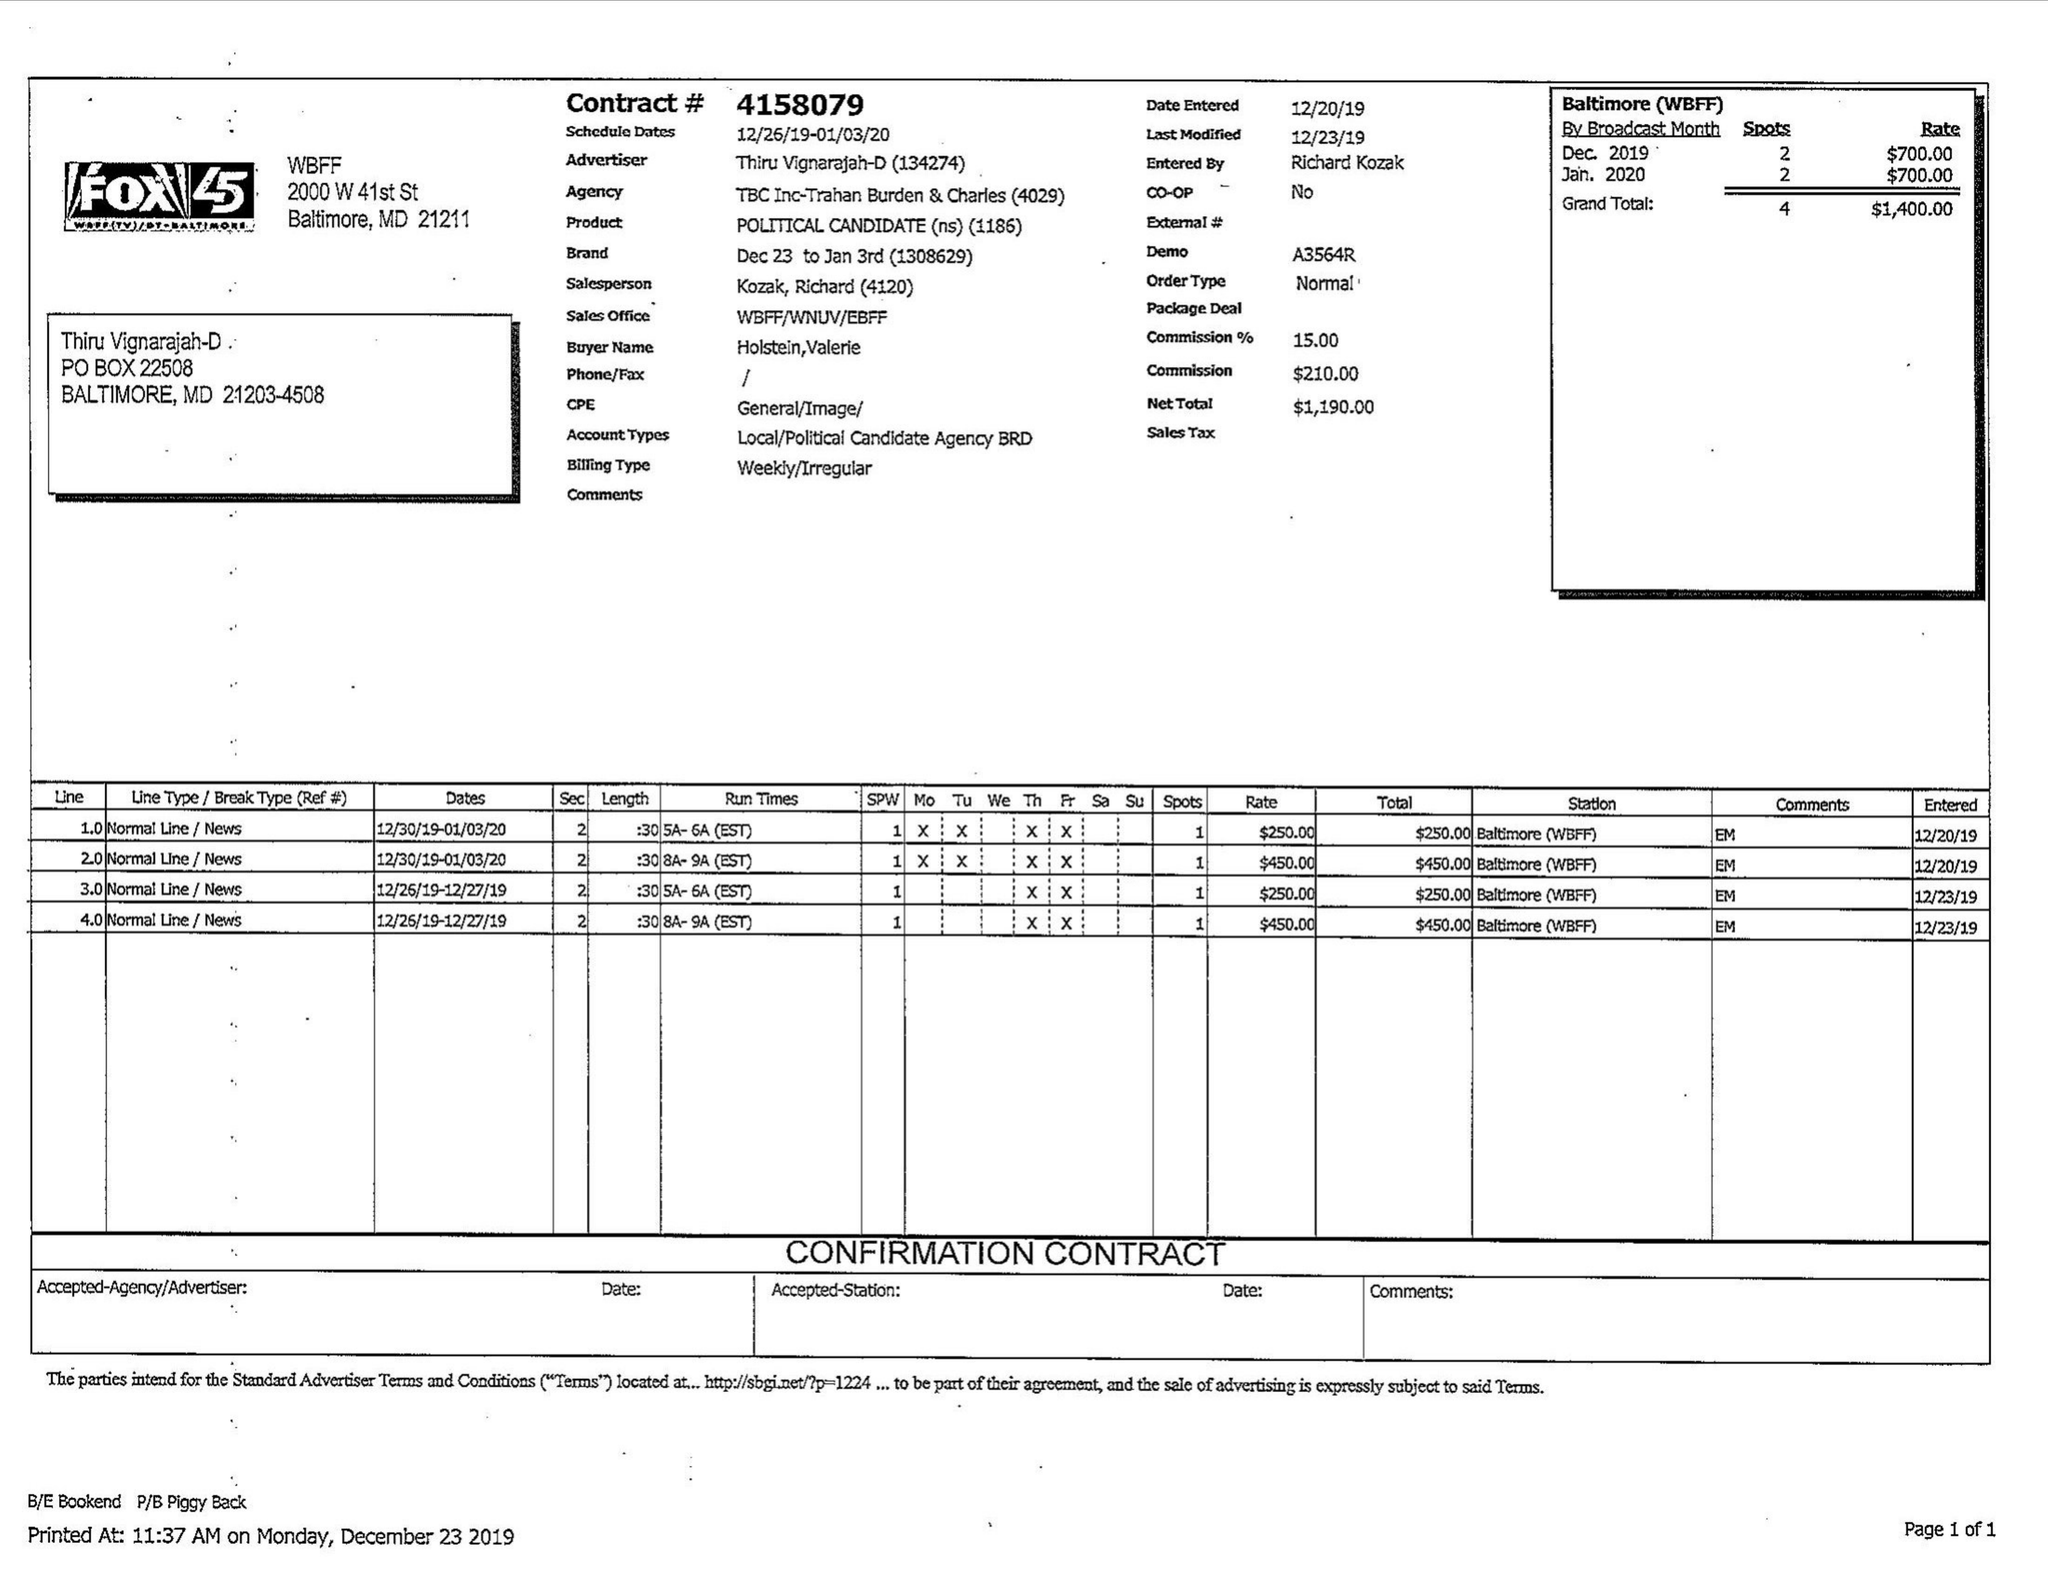What is the value for the gross_amount?
Answer the question using a single word or phrase. 1400.00 